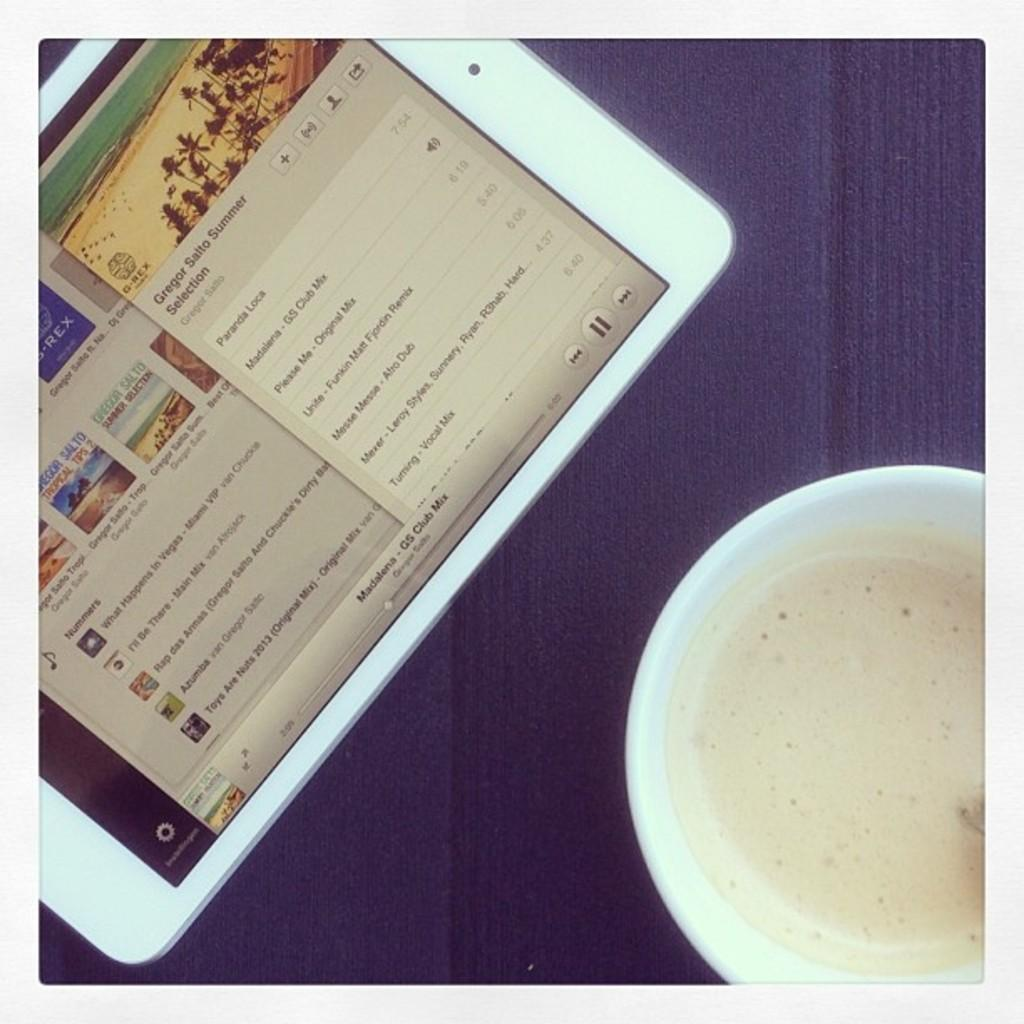What electronic device is visible in the image? There is an iPad in the image. What is the color of the surface on which the iPad is placed? The iPad is on a purple surface. What type of container is present in the image? There is a glass in the image. What color is the glass? The glass is white in color. What type of plant is growing inside the iPad in the image? There is no plant growing inside the iPad in the image; it is an electronic device and not a container for plants. 